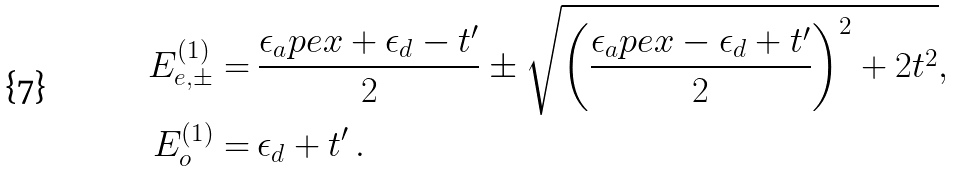<formula> <loc_0><loc_0><loc_500><loc_500>E _ { e , \pm } ^ { ( 1 ) } = & \ \frac { \epsilon _ { a } p e x + \epsilon _ { d } - t ^ { \prime } } { 2 } \pm \sqrt { \left ( \frac { \epsilon _ { a } p e x - \epsilon _ { d } + t ^ { \prime } } { 2 } \right ) ^ { 2 } + 2 t ^ { 2 } } , \\ E _ { o } ^ { ( 1 ) } = & \ \epsilon _ { d } + t ^ { \prime } \, .</formula> 